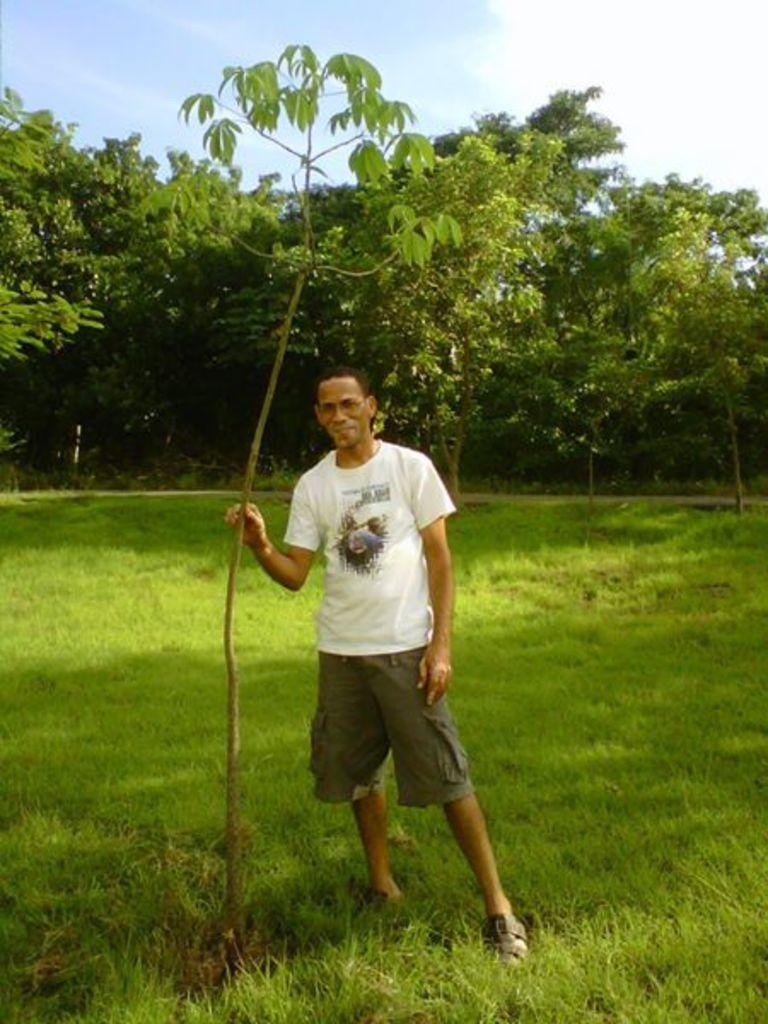What type of vegetation is present on the ground in the image? There is green grass on the ground in the image. What is the main subject in the middle of the image? There is a man standing in the middle of the image. What type of trees can be seen in the image? There are green color trees in the image. What is visible at the top of the image? The sky is visible at the top of the image. Can you see any flames coming from the trees in the image? There are no flames present in the image; it features green trees. What type of knowledge is being shared by the man in the image? The image does not provide any information about the man sharing knowledge or any specific topic. 